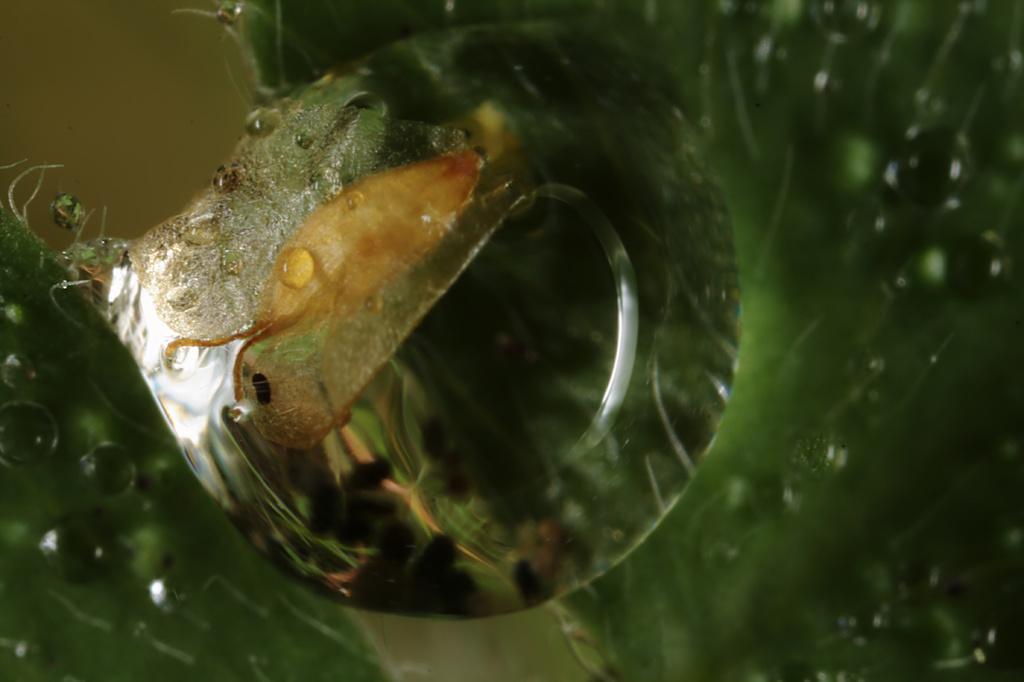Describe this image in one or two sentences. In this image we can see a green color object with water droplets. 